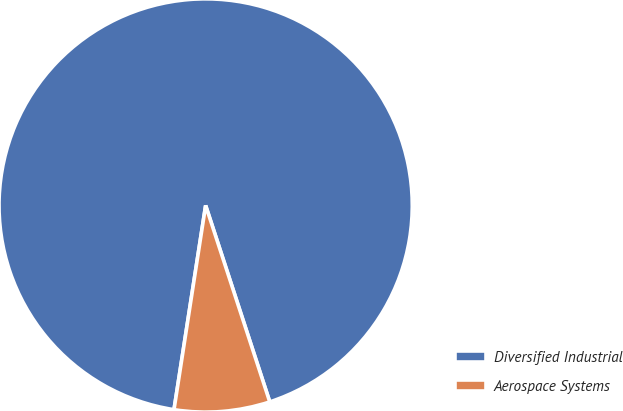Convert chart to OTSL. <chart><loc_0><loc_0><loc_500><loc_500><pie_chart><fcel>Diversified Industrial<fcel>Aerospace Systems<nl><fcel>92.53%<fcel>7.47%<nl></chart> 